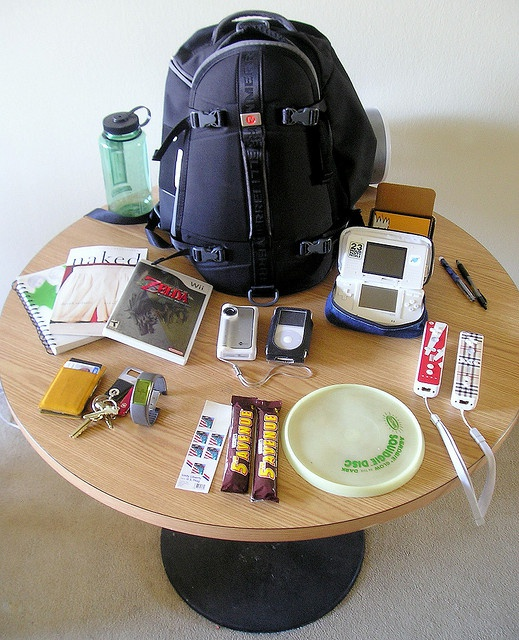Describe the objects in this image and their specific colors. I can see dining table in white, black, lightgray, and tan tones, backpack in white, black, and gray tones, frisbee in white, beige, and tan tones, book in white, gray, darkgray, and black tones, and book in white, lightgray, darkgray, gray, and tan tones in this image. 